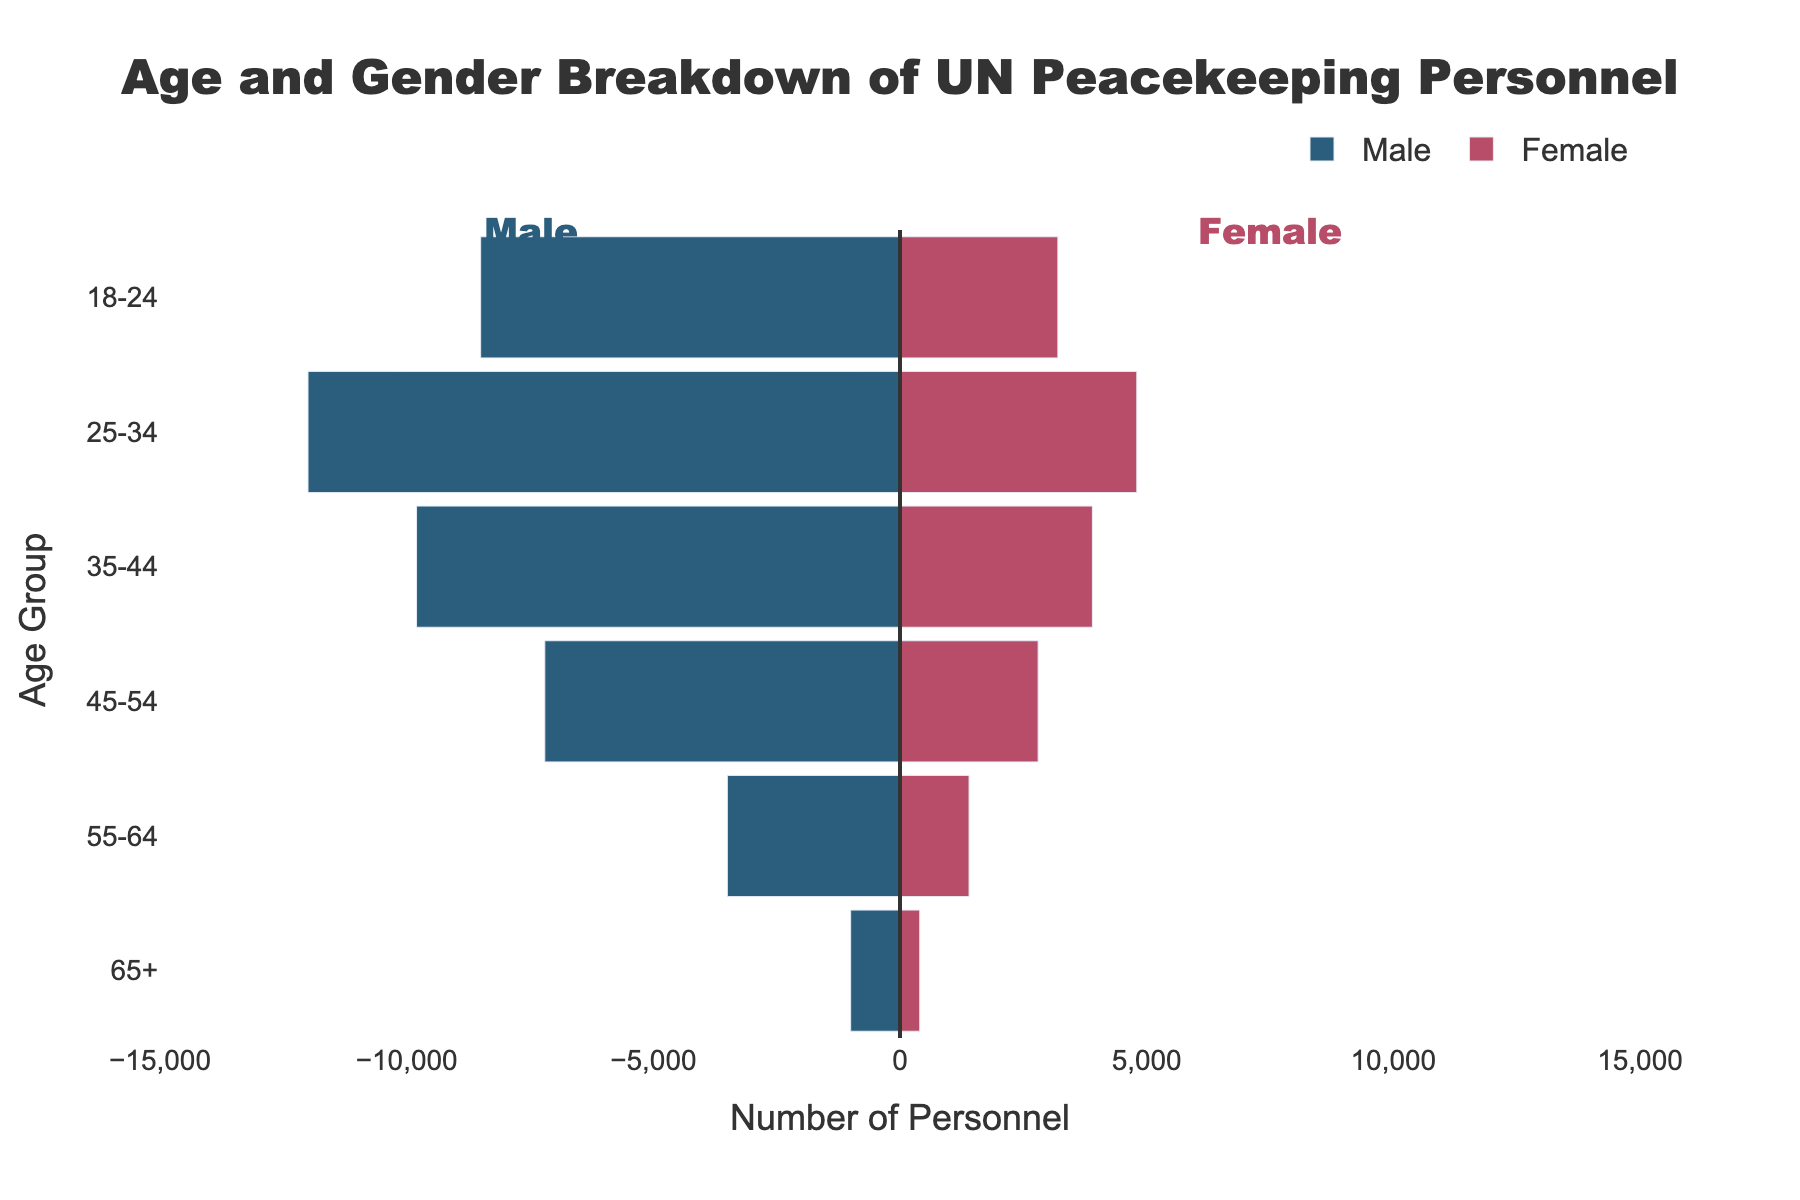What's the total number of male and female personnel in the 35-44 age group? To find the total number of personnel in the 35-44 age group, sum the number of male and female personnel in that group: 9800 (Male) + 3900 (Female) = 13700
Answer: 13700 Which gender has a higher number of personnel in the 25-34 age group? Compare the number of male personnel (12000) to the number of female personnel (4800) in the 25-34 age group. Since 12000 > 4800, males have a higher number.
Answer: Male What is the age group with the least number of male personnel? Look at the values for male personnel in all age groups. The 65+ group has the smallest number, which is 1000.
Answer: 65+ What is the percentage of female personnel in the 55-64 age group? First, calculate the total number of personnel in the 55-64 age group: 3500 (Male) + 1400 (Female) = 4900. Then, calculate the percentage of female personnel: (1400 / 4900) * 100 ≈ 28.57%.
Answer: 28.57% What is the median number of male personnel across all age groups? List the male personnel numbers in ascending order: 1000, 3500, 7200, 8500, 9800, 12000. Since there are 6 values, take the average of the 3rd and 4th value: (7200 + 8500) / 2 = 7850.
Answer: 7850 How many more male personnel are there compared to female personnel in the 45-54 age group? Subtract the number of female personnel from the number of male personnel in the 45-54 age group: 7200 (Male) - 2800 (Female) = 4400
Answer: 4400 